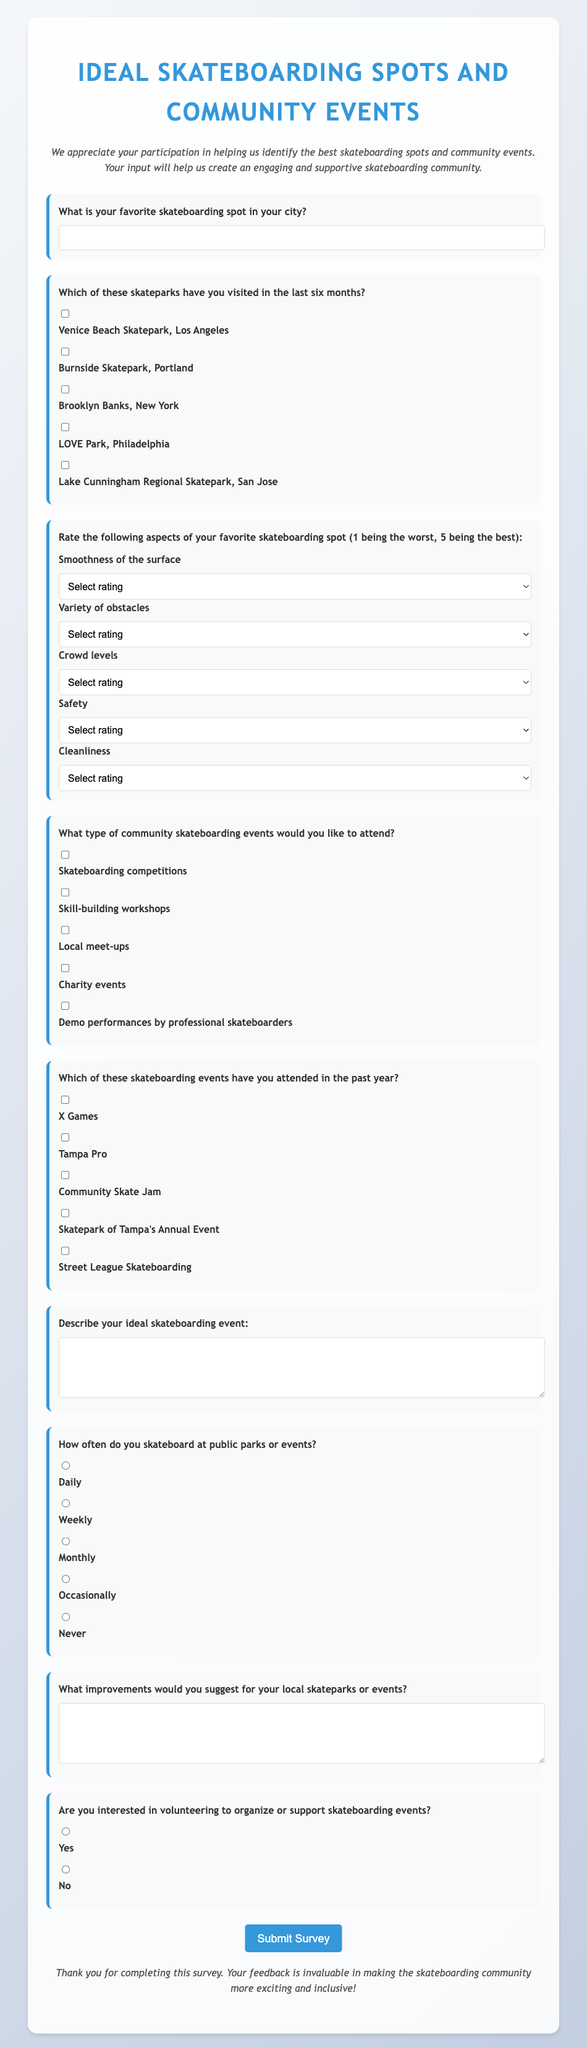What is the title of the survey? The title of the survey is found at the top of the document.
Answer: Ideal Skateboarding Spots and Community Events What is the required input for the question about favorite skateboarding spots? The question indicates that respondents must provide their favorite skateboarding spot, which is a text input.
Answer: Text input How many skateparks are listed for visitation in the last six months? The document provides a checkbox list of skateparks to choose from, which totals five.
Answer: Five What rating scale is used for assessing aspects of a favorite skateboarding spot? The rating for aspects is from 1 to 5, where 1 is the worst and 5 is the best.
Answer: 1 to 5 What type of events are respondents interested in attending? The document lists specific event types respondents can select regarding community skateboarding events.
Answer: Various types of events Which event is mentioned as a possible attendance option in the past year? The survey provides checkboxes for several events, including X Games.
Answer: X Games How often do participants skateboard at public parks or events? The survey provides radio buttons for selecting the frequency of skateboarding activity.
Answer: Frequency options What is one type of improvement respondents are asked to suggest for skateparks or events? The survey contains a question prompting respondents for suggestions regarding improvements for skateparks.
Answer: Suggestions for improvements Are respondents given an option to volunteer for skateboarding events? The document includes a question about volunteering, which has Yes or No radio button options.
Answer: Yes or No 